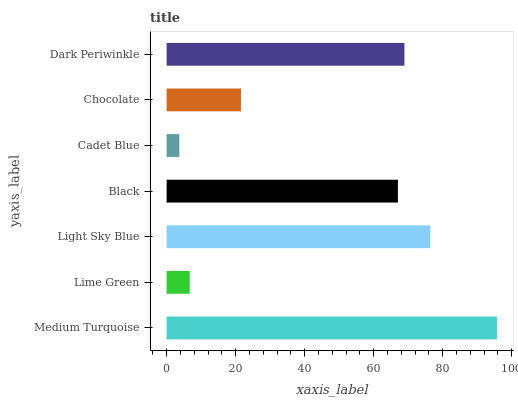Is Cadet Blue the minimum?
Answer yes or no. Yes. Is Medium Turquoise the maximum?
Answer yes or no. Yes. Is Lime Green the minimum?
Answer yes or no. No. Is Lime Green the maximum?
Answer yes or no. No. Is Medium Turquoise greater than Lime Green?
Answer yes or no. Yes. Is Lime Green less than Medium Turquoise?
Answer yes or no. Yes. Is Lime Green greater than Medium Turquoise?
Answer yes or no. No. Is Medium Turquoise less than Lime Green?
Answer yes or no. No. Is Black the high median?
Answer yes or no. Yes. Is Black the low median?
Answer yes or no. Yes. Is Dark Periwinkle the high median?
Answer yes or no. No. Is Medium Turquoise the low median?
Answer yes or no. No. 